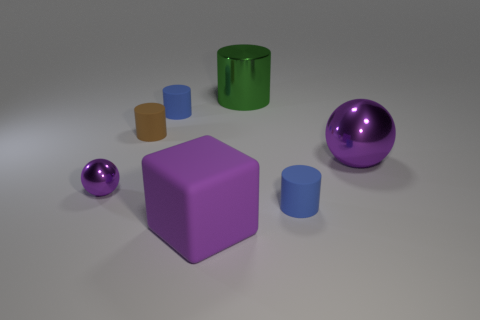How many brown things have the same shape as the large green shiny object?
Your answer should be very brief. 1. What is the color of the big thing that is in front of the large metal cylinder and behind the tiny ball?
Offer a terse response. Purple. How many small brown matte objects are there?
Provide a short and direct response. 1. Do the green cylinder and the rubber cube have the same size?
Keep it short and to the point. Yes. Are there any small matte cylinders of the same color as the large matte object?
Provide a short and direct response. No. Is the shape of the shiny object right of the green shiny thing the same as  the green metallic thing?
Offer a terse response. No. What number of purple things are the same size as the purple matte cube?
Give a very brief answer. 1. There is a small matte object that is in front of the tiny purple ball; how many large metallic balls are in front of it?
Your answer should be very brief. 0. Is the large thing that is on the right side of the large green metal cylinder made of the same material as the big purple cube?
Your answer should be very brief. No. Is the cylinder in front of the small brown object made of the same material as the purple ball that is to the left of the large shiny sphere?
Your answer should be very brief. No. 